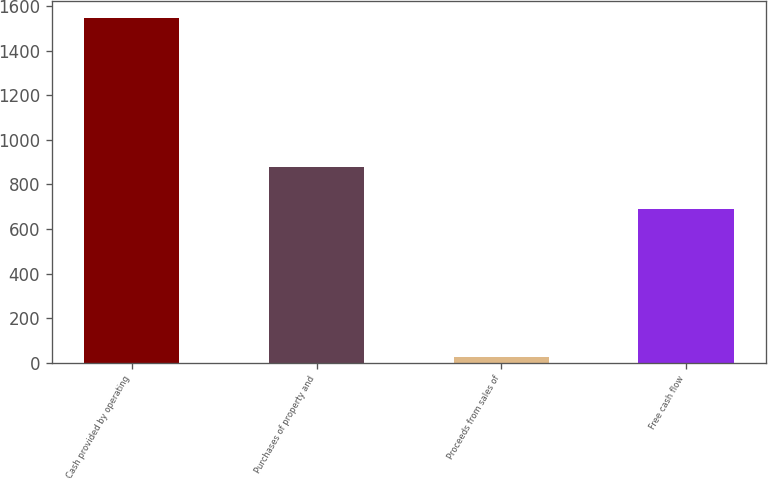Convert chart. <chart><loc_0><loc_0><loc_500><loc_500><bar_chart><fcel>Cash provided by operating<fcel>Purchases of property and<fcel>Proceeds from sales of<fcel>Free cash flow<nl><fcel>1548.2<fcel>880.8<fcel>23.9<fcel>691.3<nl></chart> 